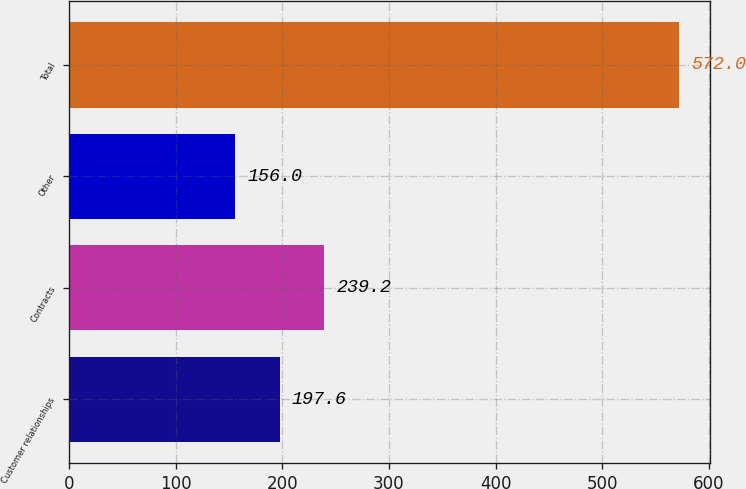Convert chart. <chart><loc_0><loc_0><loc_500><loc_500><bar_chart><fcel>Customer relationships<fcel>Contracts<fcel>Other<fcel>Total<nl><fcel>197.6<fcel>239.2<fcel>156<fcel>572<nl></chart> 